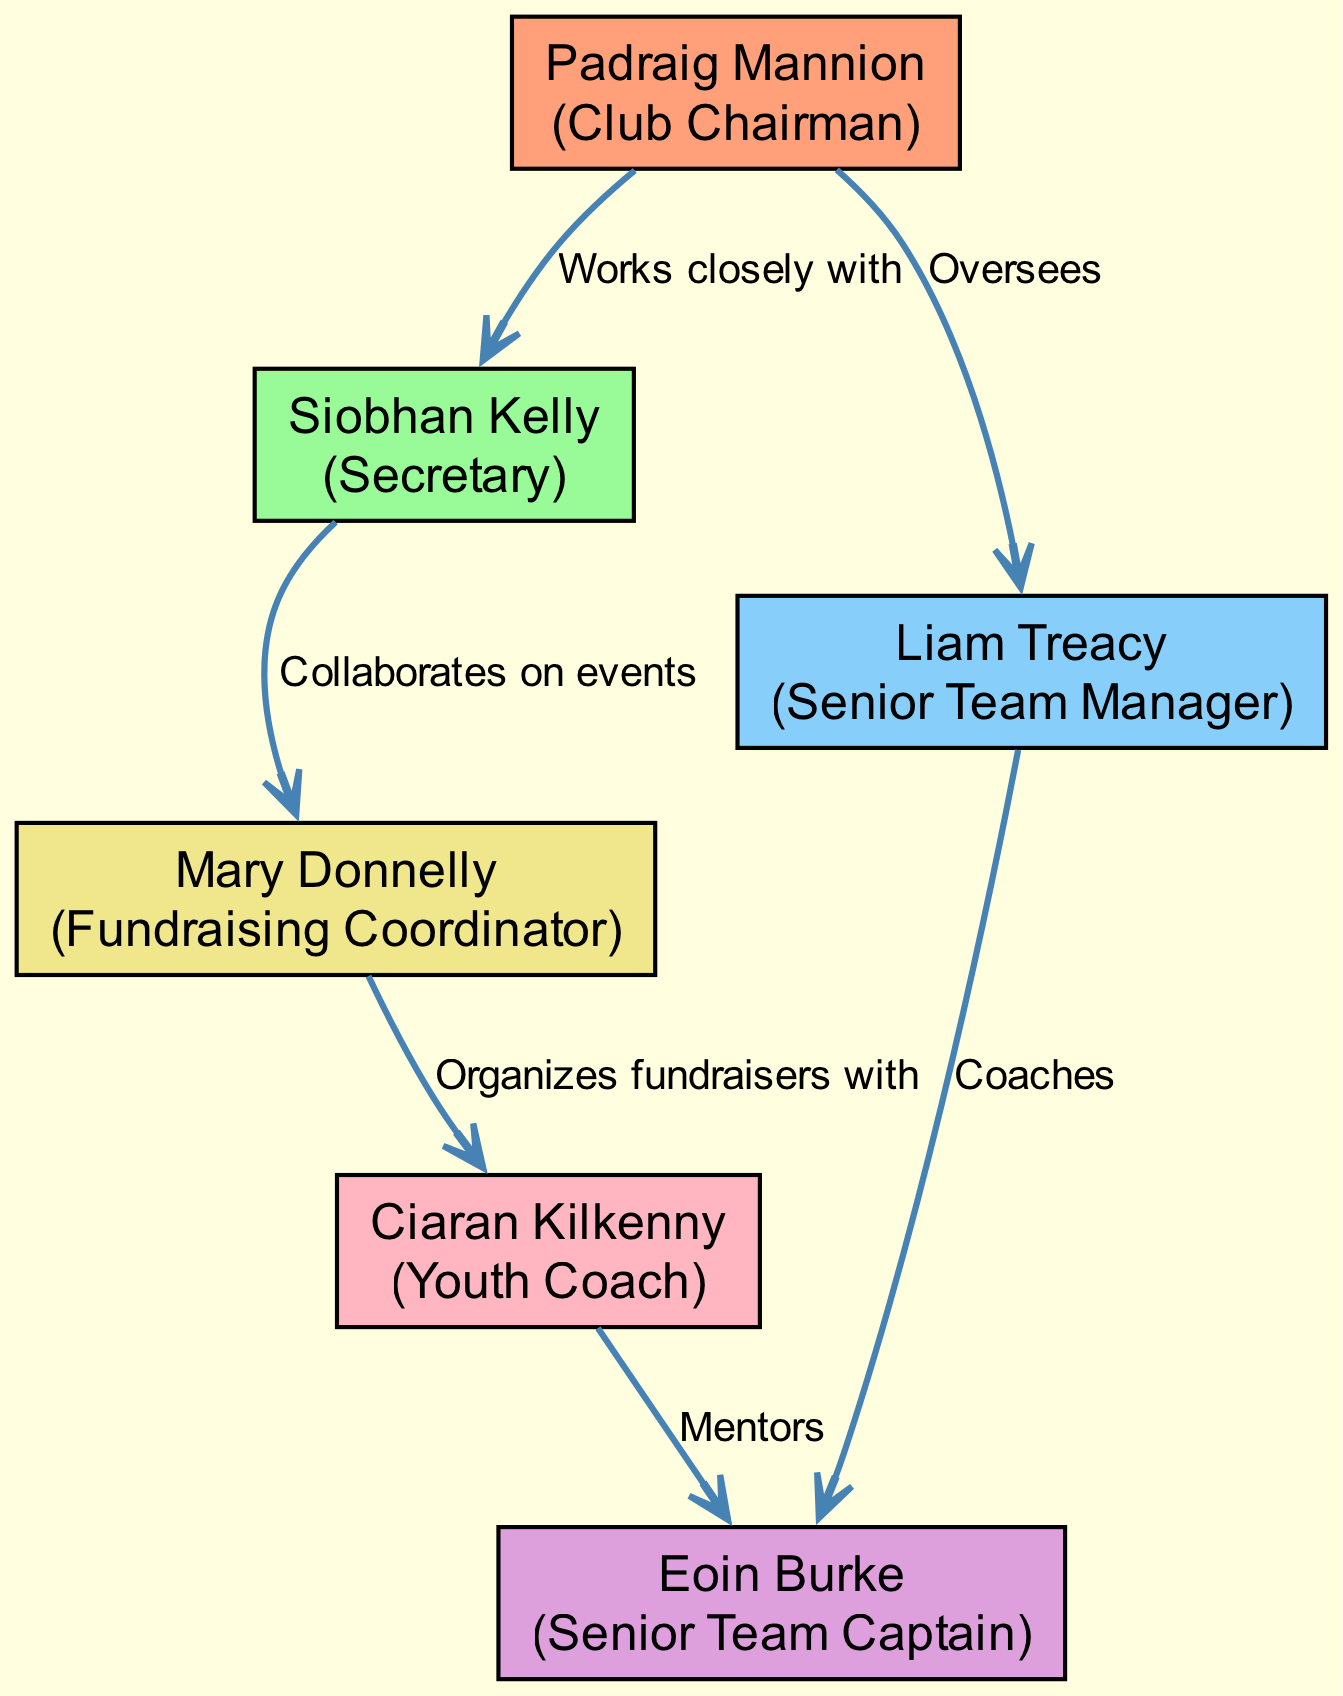What is the role of Padraig Mannion? Looking at the diagram, Padraig Mannion is identified as the "Club Chairman" in the node labeled with his name.
Answer: Club Chairman How many members are there in total? By counting the unique node entries on the diagram, we find that there are a total of six members listed.
Answer: 6 What relationship exists between Siobhan Kelly and Mary Donnelly? The diagram specifies that Siobhan Kelly "Collaborates on events" with Mary Donnelly, as indicated by the edge connecting their nodes.
Answer: Collaborates on events Who does Eoin Burke coach? The diagram indicates that Eoin Burke is coached by Liam Treacy, as shown by the directed edge from Liam Treacy to Eoin Burke labeled "Coaches."
Answer: Liam Treacy Which role has the least connections in the network? By analyzing the connections in the diagram, we can see that "Youth Coach," represented by Ciaran Kilkenny, only has one connection, making it the role with the least connections.
Answer: Youth Coach What is the connection between Ciaran Kilkenny and Eoin Burke? The diagram indicates that Ciaran Kilkenny is depicted in a mentoring role relative to Eoin Burke, as suggested by the edge labeled "Mentors."
Answer: Mentors Who oversees the Senior Team Manager? The diagram shows that Padraig Mannion oversees Liam Treacy, as suggested by the edge labeled "Oversees" that connects the two.
Answer: Padraig Mannion How many different roles are there in the network? By looking closely at the nodes, we can categorize the roles and find that there are six distinct roles represented in the diagram.
Answer: 6 What common task do Siobhan Kelly and Mary Donnelly share? The diagram shows that Siobhan Kelly and Mary Donnelly both involve themselves in organizing events, with the edge indicating they "Collaborate on events."
Answer: Collaborate on events 